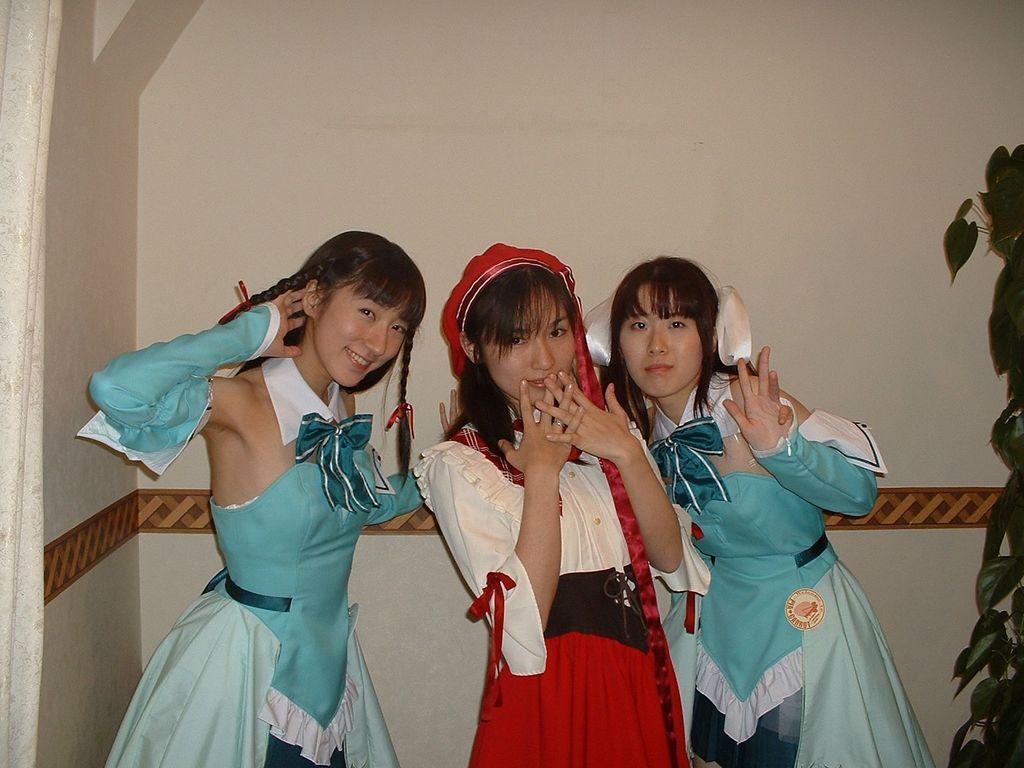Describe this image in one or two sentences. Here in this picture we can see three women standing over a place in a traditional dress and we can see all of them are smiling and beside them on right side we can see a plant present over there. 